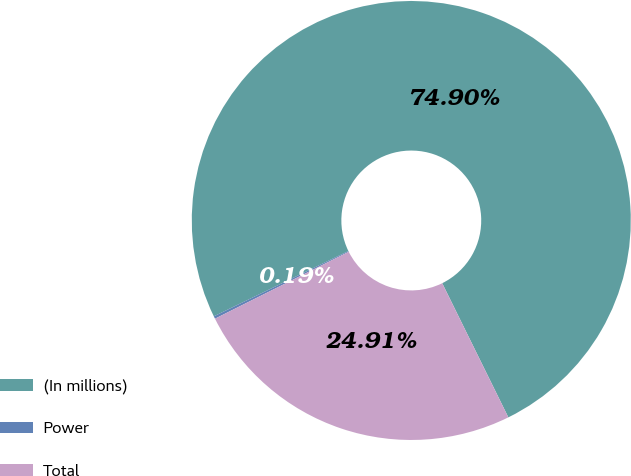Convert chart to OTSL. <chart><loc_0><loc_0><loc_500><loc_500><pie_chart><fcel>(In millions)<fcel>Power<fcel>Total<nl><fcel>74.91%<fcel>0.19%<fcel>24.91%<nl></chart> 